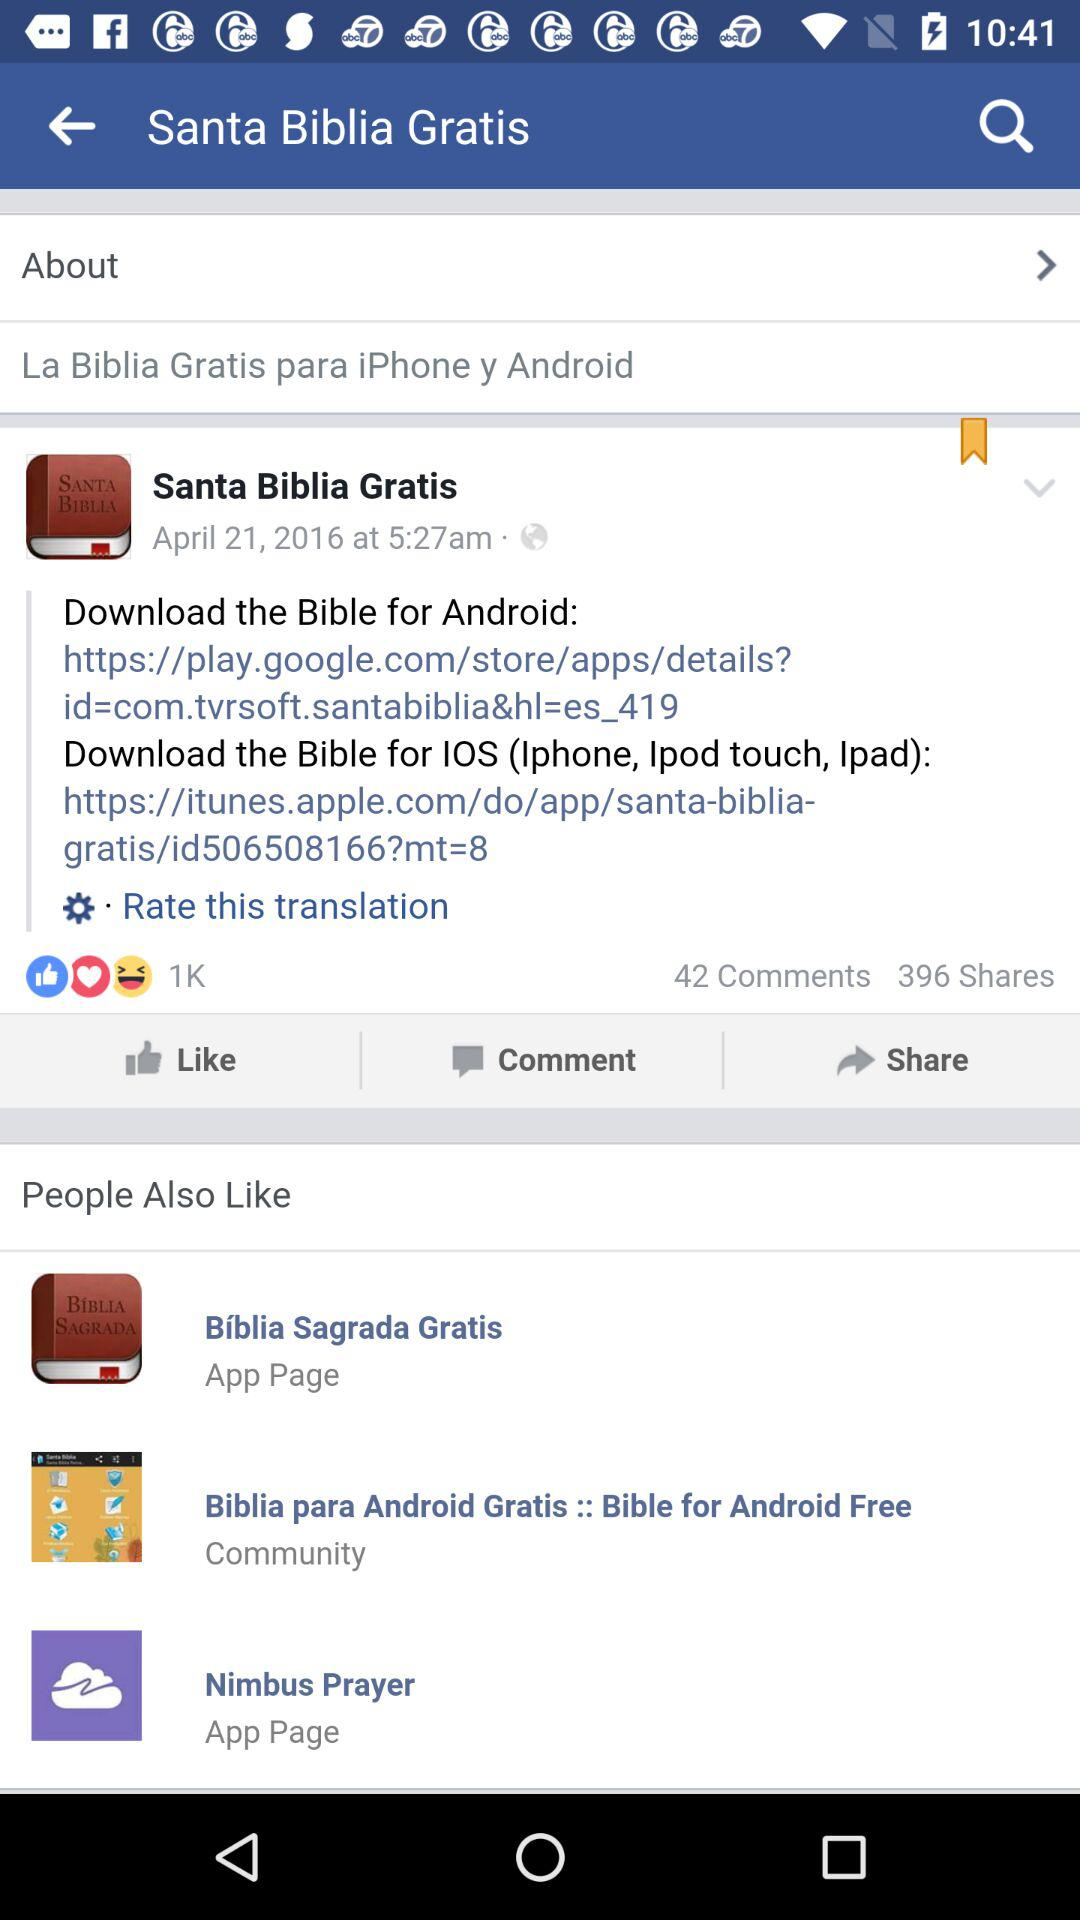When was the post posted? The post was posted at 5:27 a.m. 